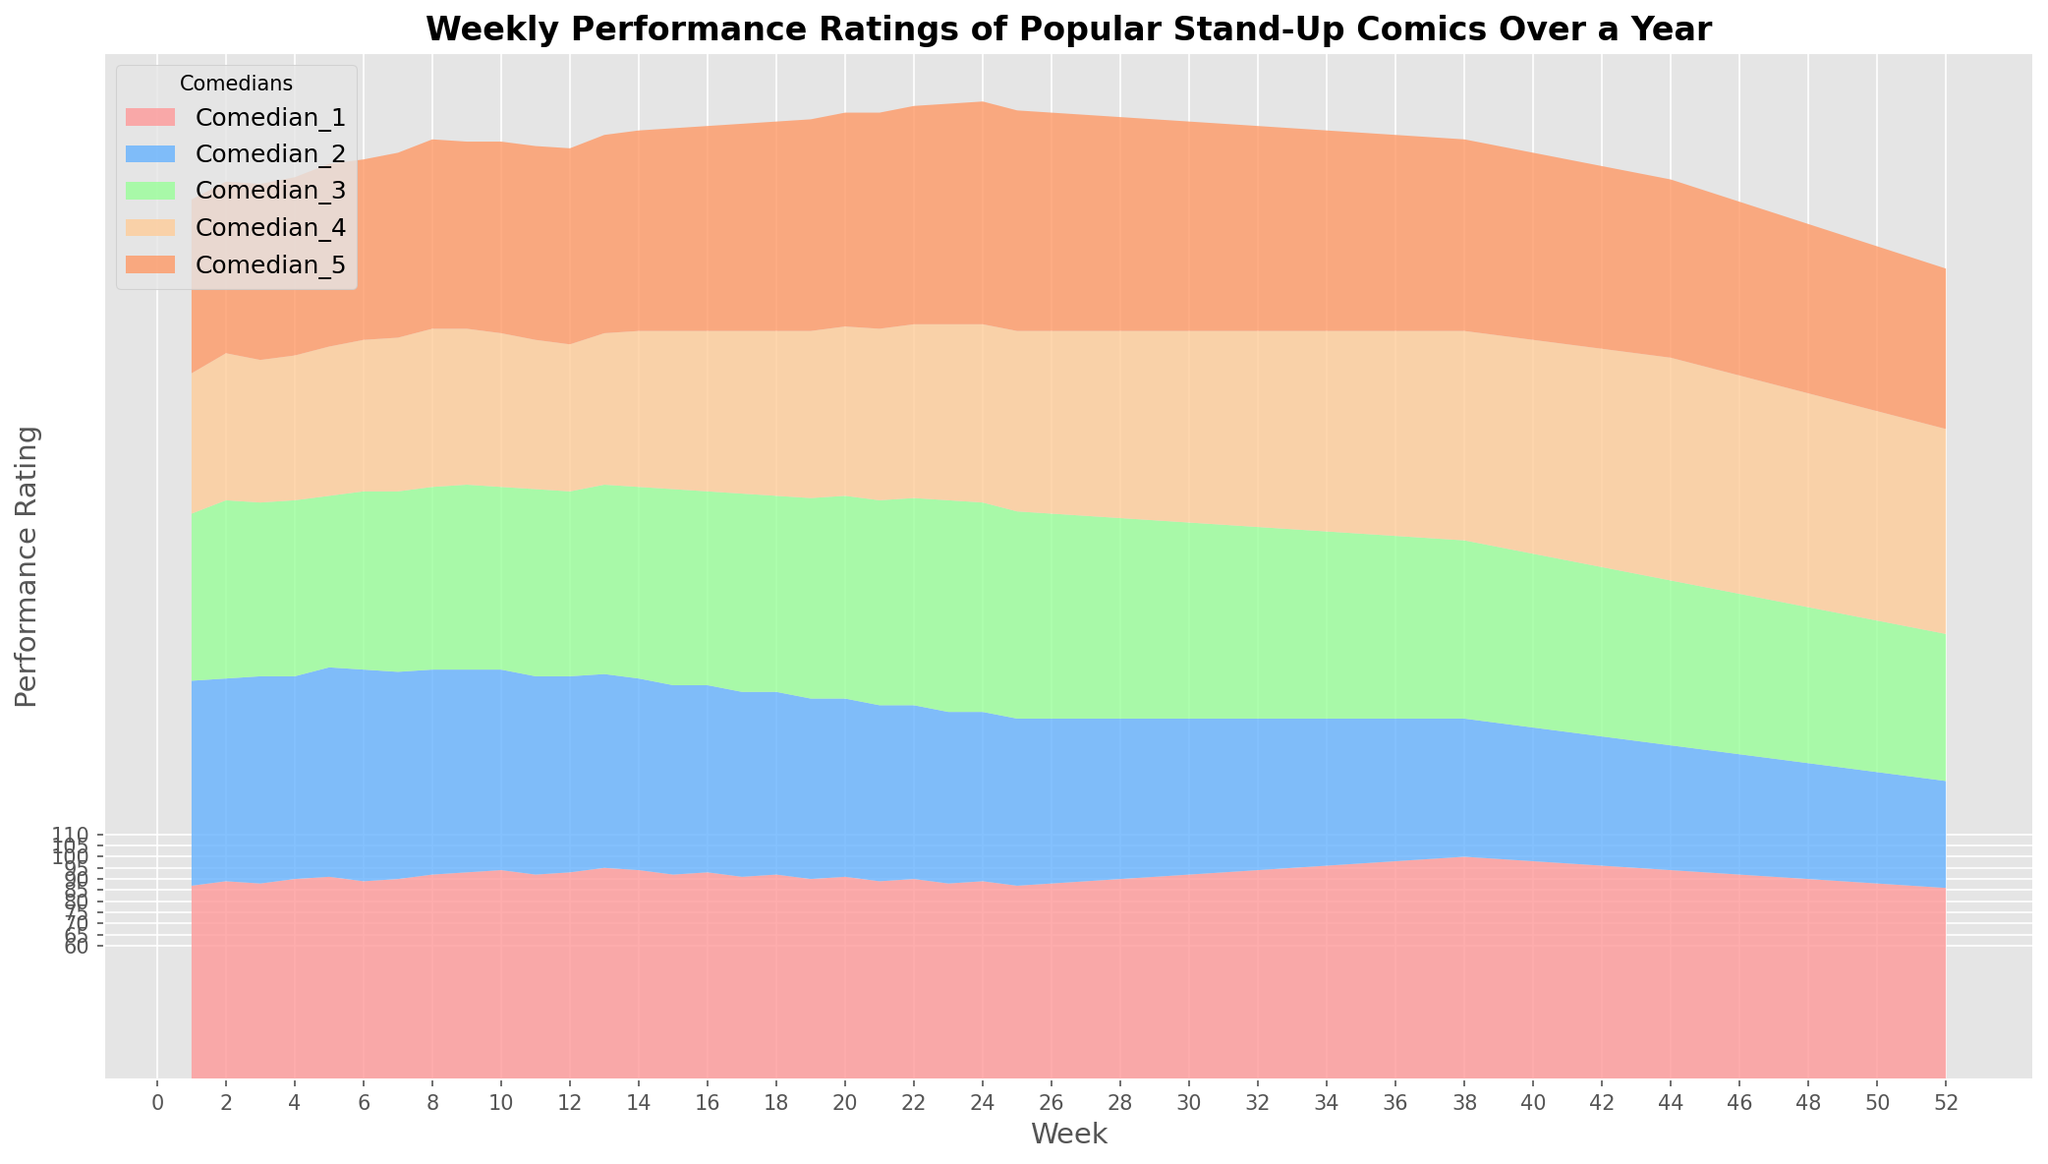What trend is observed for Comedian 1 over the year? Comedian 1's ratings start at 87 in week 1 and steadily increase, peaking at 100 in week 38. Afterward, the ratings gradually decline to 86 by week 52. Hence, a general increasing trend until week 38, followed by a decline.
Answer: Increasing until week 38, then decreasing Which comedian has the most significant performance drop, and when? Comedian 2 has the most significant drop in ratings, going from 95 in week 6 to 48 in week 52.
Answer: Comedian 2 from week 6 to week 52 During which weeks do Comedian 3 and Comedian 4 have roughly equal performance? Comedian 3 and Comedian 4 have similar ratings around weeks 19-21 and again around weeks 31-32, when their ratings hover around 89-91.
Answer: Weeks 19-21 and 31-32 What's the difference in performance between Comedian 4 and Comedian 5 in the last week? In week 52, Comedian 4's rating is 92, and Comedian 5's rating is 72. The difference is 92 - 72 = 20.
Answer: 20 Which comedian shows the most consistent performance throughout the year? Comedian 1 shows a steady increase and then a steady decline, whereas others have more abrupt changes. The steadiness of Comedian 1's changes indicates the most consistency.
Answer: Comedian 1 By how many points did Comedian 5 improve from the beginning to the end of the year? Comedian 5's rating starts at 78 in week 1 and ends at 72 in week 52. The improvement is 72 - 78 = -6, indicating a decrease.
Answer: -6 What is the combined rating for all comedians in week 20? Adding the ratings in week 20: 91 (Comedian 1) + 80 (Comedian 2) + 91 (Comedian 3) + 76 (Comedian 4) + 96 (Comedian 5) = 434.
Answer: 434 During which week does Comedian 3 peak in performance throughout the year? Comedian 3 peaks at a rating of 95 during week 23.
Answer: Week 23 Between which weeks does Comedian 4's performance increase the most? Comedian 4 increases from 63 in week 1 to a peak of 100 in week 44, showing a steady climb, with the most significant increases in the later weeks, particularly around week 34-44.
Answer: Weeks 34-44 Which color represents Comedian 2, and how does it help distinguish their performance trend? Comedian 2 is represented by light blue. This color helps to visualize the steep decline after week 6 and the distinction from other comedians’ trends.
Answer: Light blue 